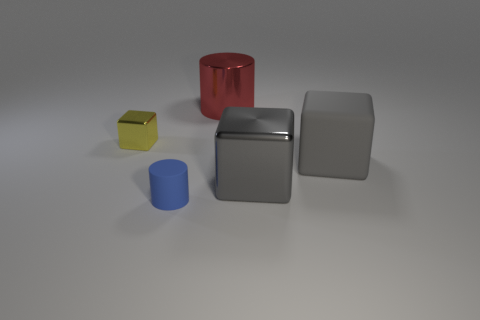There is a thing that is both behind the gray rubber block and to the left of the big red cylinder; what color is it?
Provide a succinct answer. Yellow. How many other objects are the same color as the tiny shiny object?
Provide a succinct answer. 0. What is the material of the small object behind the big thing to the right of the metallic object that is on the right side of the big metallic cylinder?
Your answer should be very brief. Metal. How many cylinders are large red things or yellow objects?
Your answer should be compact. 1. What number of red objects are in front of the matte object that is left of the gray object on the right side of the big metal block?
Keep it short and to the point. 0. Does the small yellow metallic thing have the same shape as the blue rubber object?
Offer a terse response. No. Are the object behind the tiny yellow metallic object and the large gray block in front of the big gray matte cube made of the same material?
Offer a very short reply. Yes. How many things are big objects in front of the big cylinder or gray shiny objects that are to the right of the yellow metal thing?
Your answer should be very brief. 2. What number of tiny yellow cylinders are there?
Your answer should be very brief. 0. Are there any cylinders of the same size as the yellow thing?
Your answer should be very brief. Yes. 